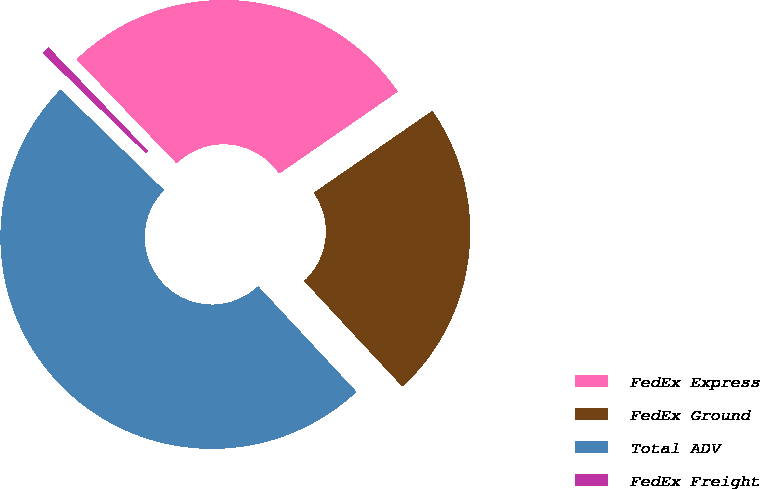Convert chart. <chart><loc_0><loc_0><loc_500><loc_500><pie_chart><fcel>FedEx Express<fcel>FedEx Ground<fcel>Total ADV<fcel>FedEx Freight<nl><fcel>27.56%<fcel>22.7%<fcel>49.2%<fcel>0.54%<nl></chart> 